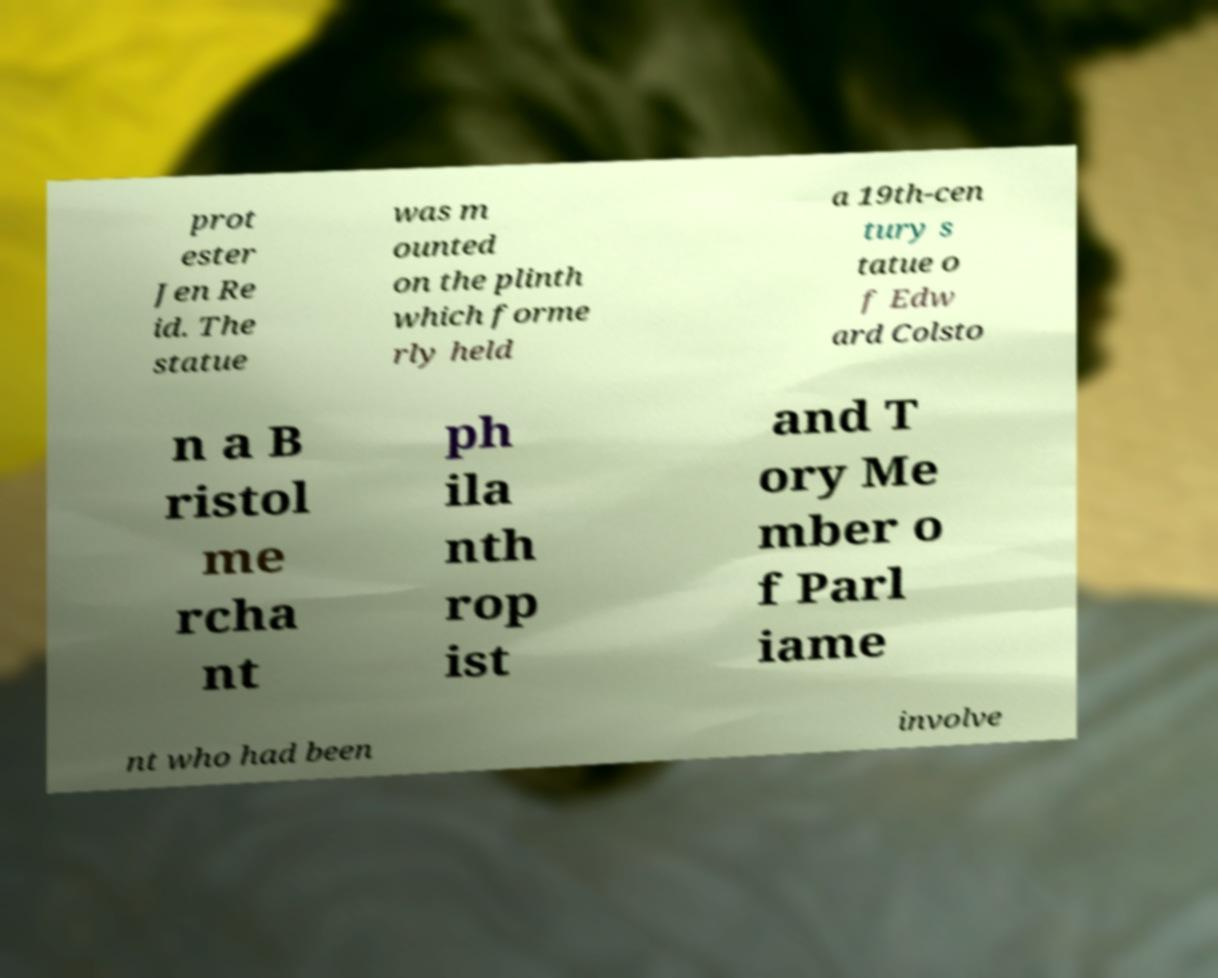Please identify and transcribe the text found in this image. prot ester Jen Re id. The statue was m ounted on the plinth which forme rly held a 19th-cen tury s tatue o f Edw ard Colsto n a B ristol me rcha nt ph ila nth rop ist and T ory Me mber o f Parl iame nt who had been involve 